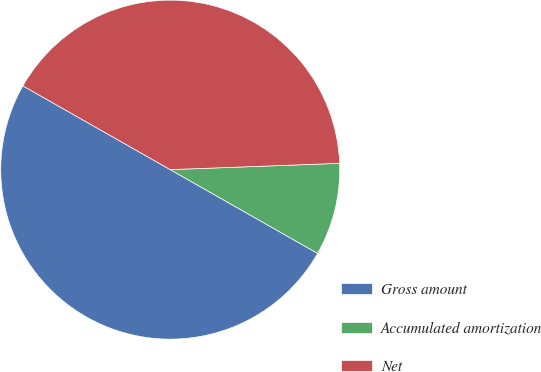Convert chart. <chart><loc_0><loc_0><loc_500><loc_500><pie_chart><fcel>Gross amount<fcel>Accumulated amortization<fcel>Net<nl><fcel>50.0%<fcel>8.82%<fcel>41.18%<nl></chart> 